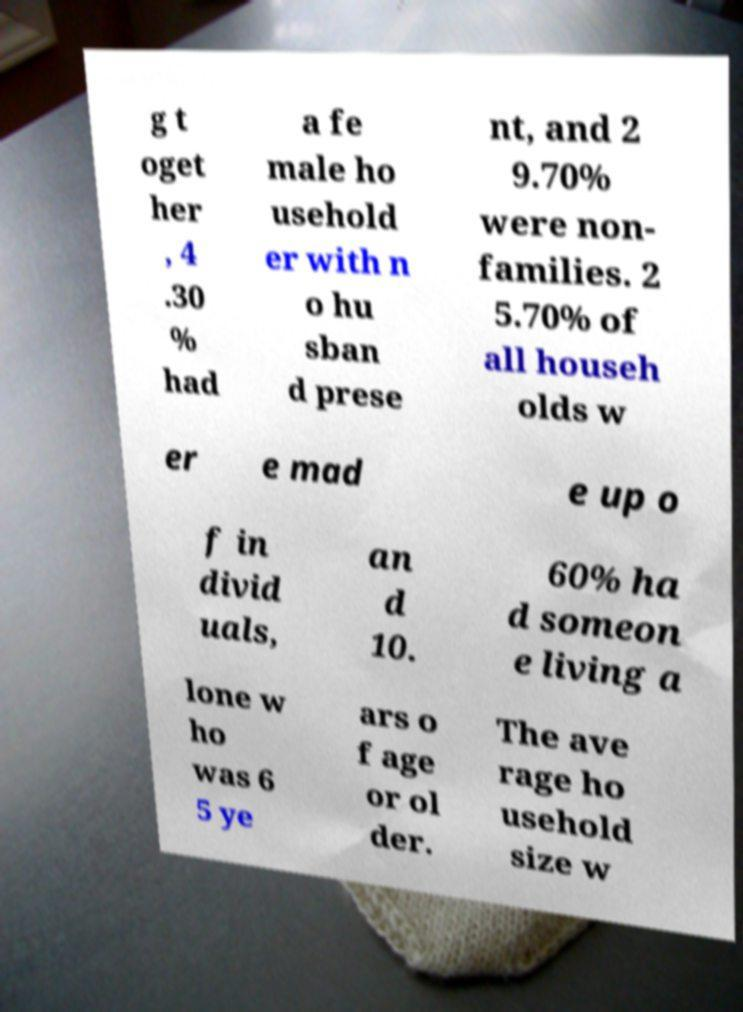For documentation purposes, I need the text within this image transcribed. Could you provide that? g t oget her , 4 .30 % had a fe male ho usehold er with n o hu sban d prese nt, and 2 9.70% were non- families. 2 5.70% of all househ olds w er e mad e up o f in divid uals, an d 10. 60% ha d someon e living a lone w ho was 6 5 ye ars o f age or ol der. The ave rage ho usehold size w 